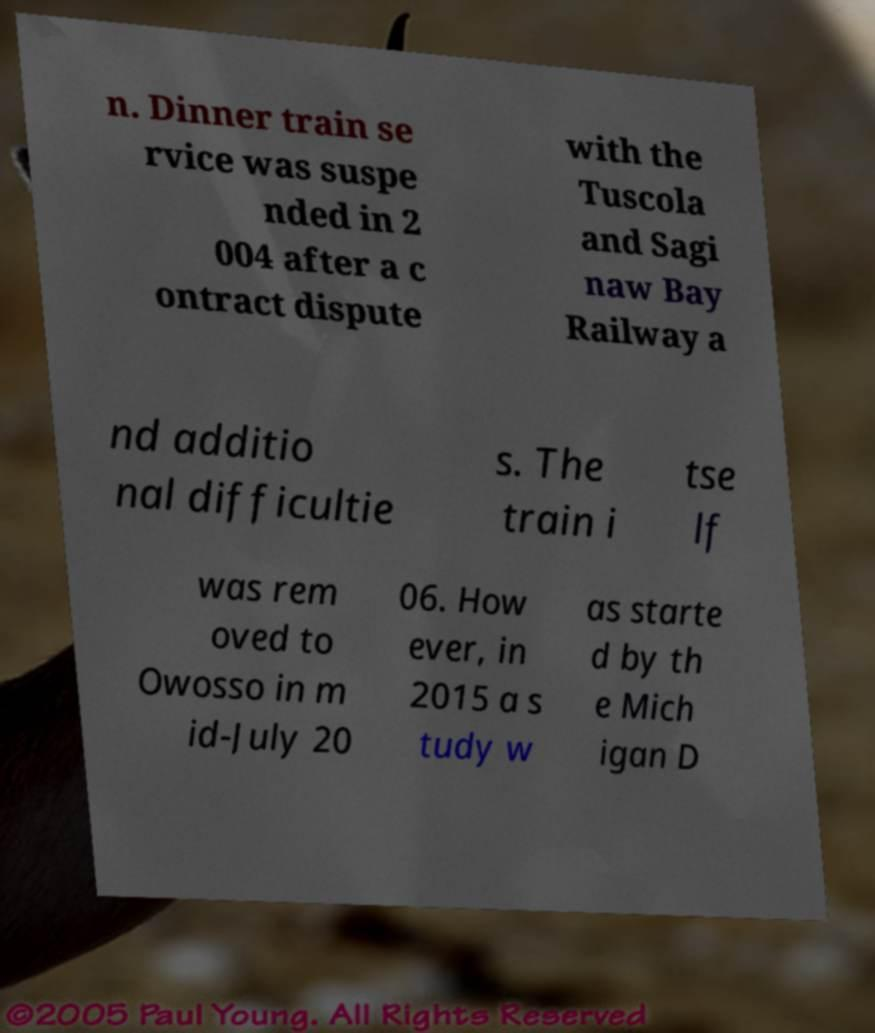What messages or text are displayed in this image? I need them in a readable, typed format. n. Dinner train se rvice was suspe nded in 2 004 after a c ontract dispute with the Tuscola and Sagi naw Bay Railway a nd additio nal difficultie s. The train i tse lf was rem oved to Owosso in m id-July 20 06. How ever, in 2015 a s tudy w as starte d by th e Mich igan D 